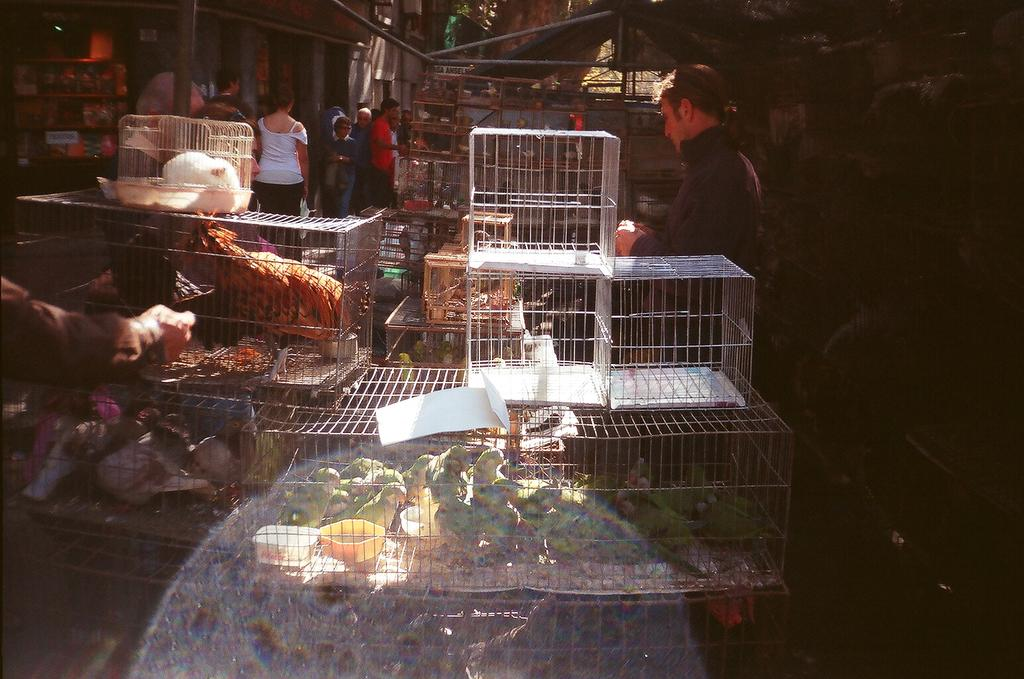What type of animals are in cages in the image? There are birds in cages in the image. What are the people in the image doing? Some people are walking, and others are standing in the image. What can be seen in the background of the image? Trees are visible in the background of the image. What type of waste can be seen on the ground in the image? There is no waste visible on the ground in the image. Can you tell me what kind of berry the birds are eating in the image? There are no berries present in the image; the birds are in cages. 